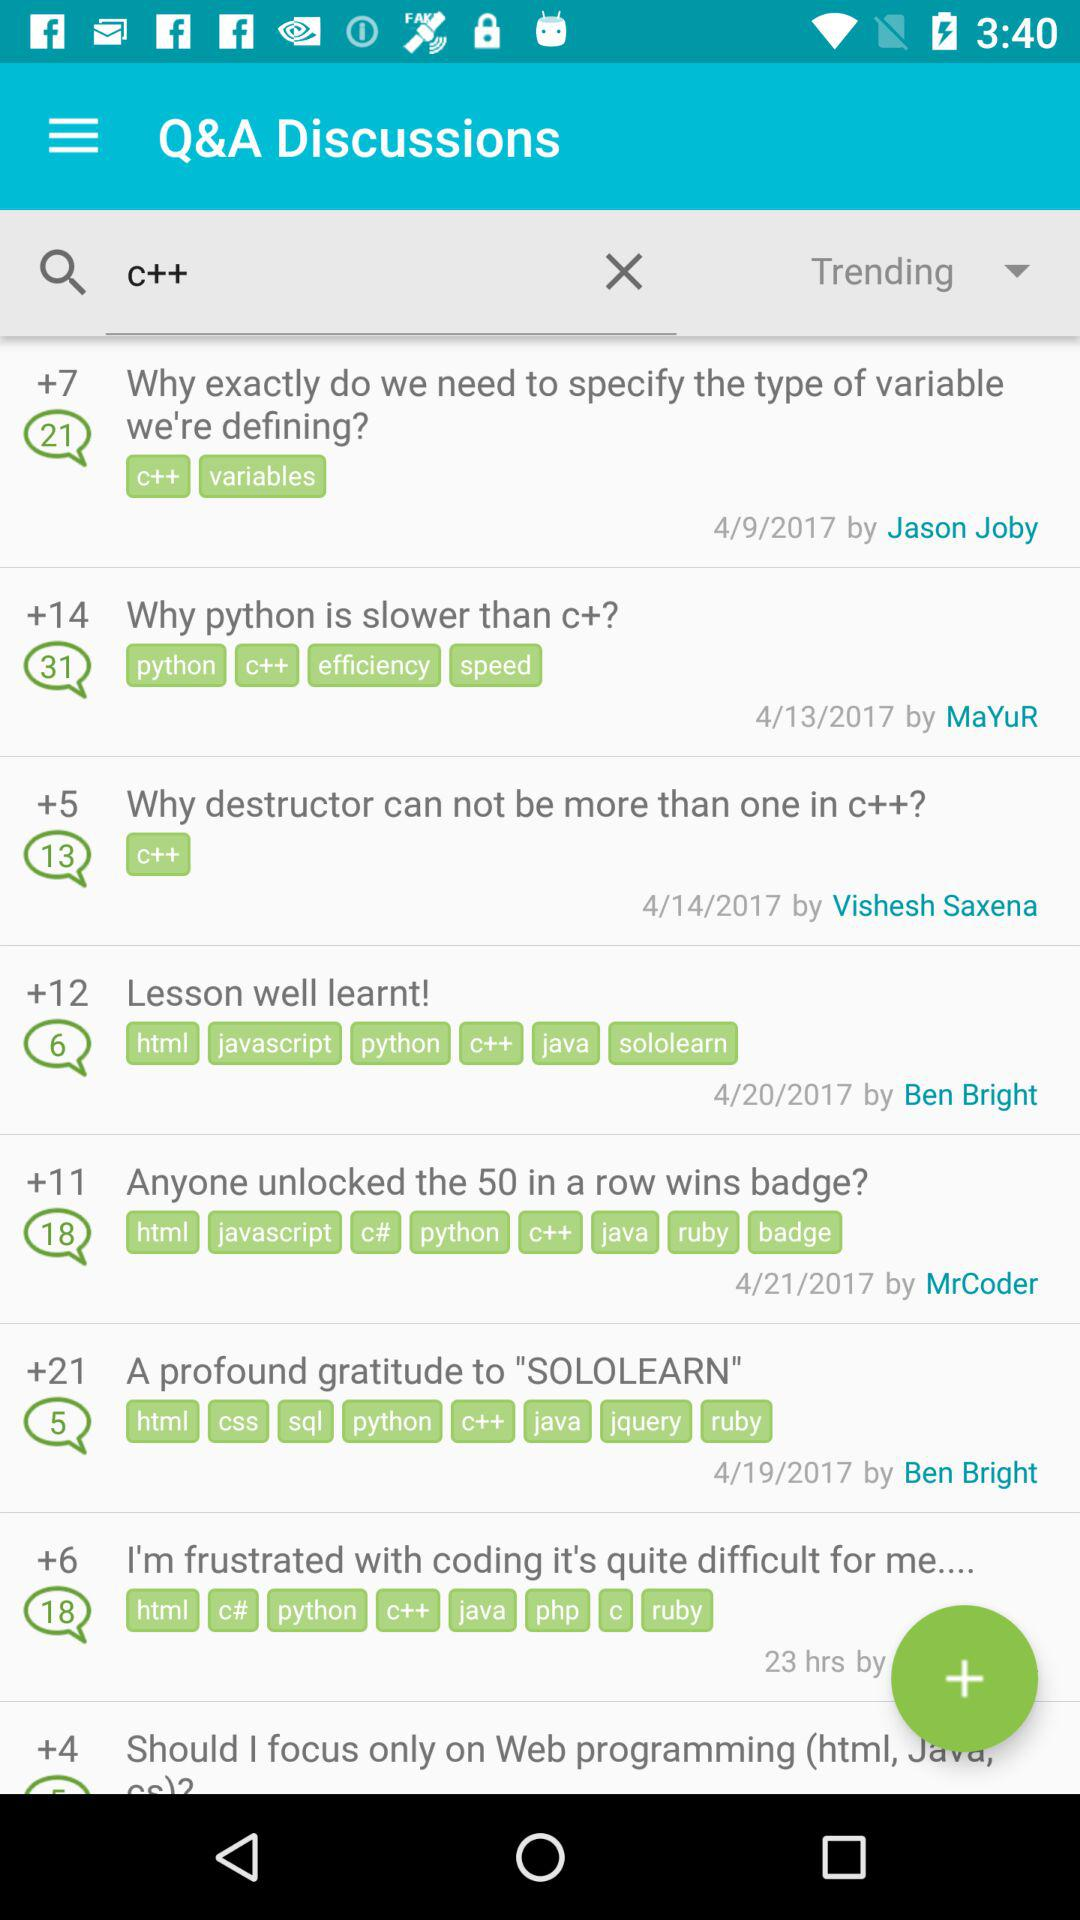How many votes were given by Jason Joby?
When the provided information is insufficient, respond with <no answer>. <no answer> 